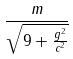Convert formula to latex. <formula><loc_0><loc_0><loc_500><loc_500>\frac { m } { \sqrt { 9 + \frac { g ^ { 2 } } { c ^ { 2 } } } }</formula> 